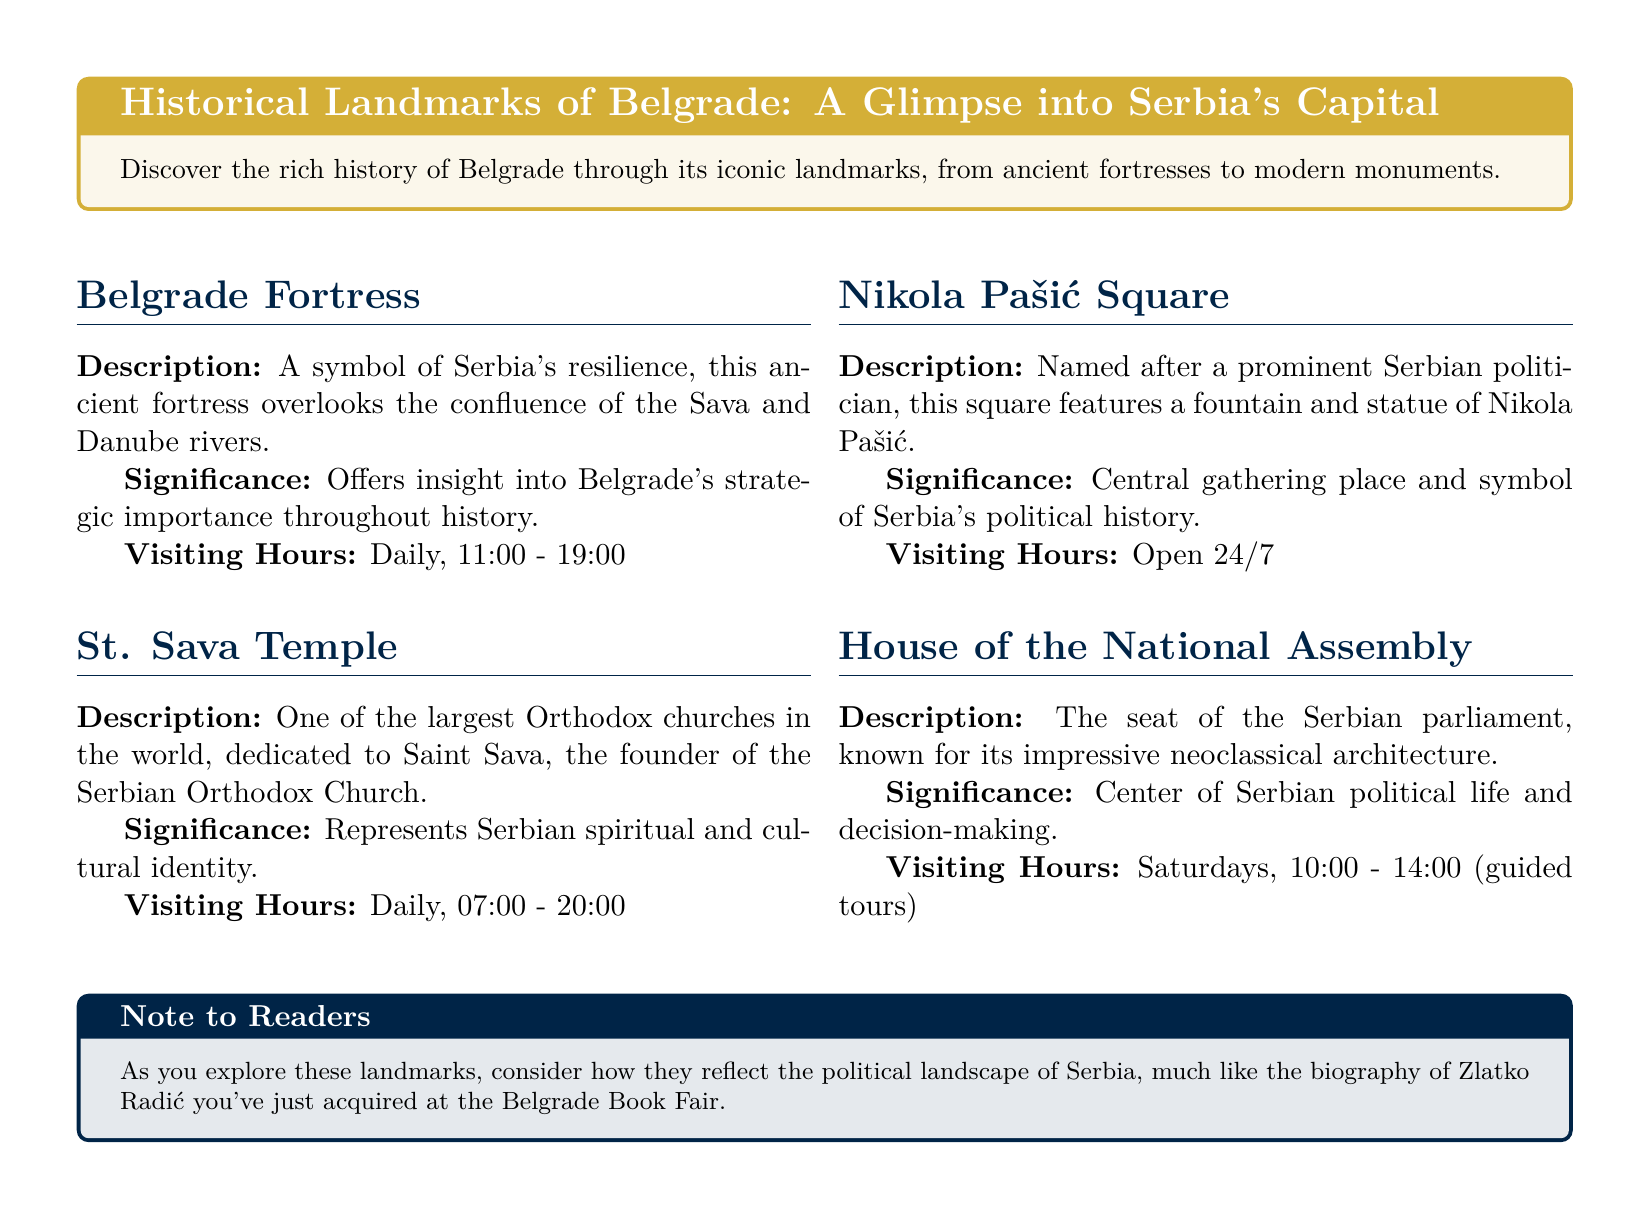What are the visiting hours for Belgrade Fortress? The visiting hours for Belgrade Fortress are listed in the document under visiting hours.
Answer: Daily, 11:00 - 19:00 What is the significance of St. Sava Temple? The significance of St. Sava Temple is described in the document, linking it to Serbian cultural identity.
Answer: Represents Serbian spiritual and cultural identity What is the description of Nikola Pašić Square? The description of Nikola Pašić Square is provided in the document.
Answer: Named after a prominent Serbian politician, this square features a fountain and statue of Nikola Pašić When can you visit the House of the National Assembly? The document specifies the visiting hours for the House of the National Assembly.
Answer: Saturdays, 10:00 - 14:00 (guided tours) What landmark reflects Serbia's political life? The document connects specific landmarks with aspects of Serbian political life.
Answer: House of the National Assembly What are the visiting hours for St. Sava Temple? The visiting hours for St. Sava Temple are stated in the document.
Answer: Daily, 07:00 - 20:00 What type of architecture is the House of the National Assembly known for? The document describes the architectural style of the House of the National Assembly.
Answer: Neoclassical architecture What does the note to readers suggest to consider while exploring landmarks? The note provides a suggestion related to exploring landmarks and their significance.
Answer: How they reflect the political landscape of Serbia 